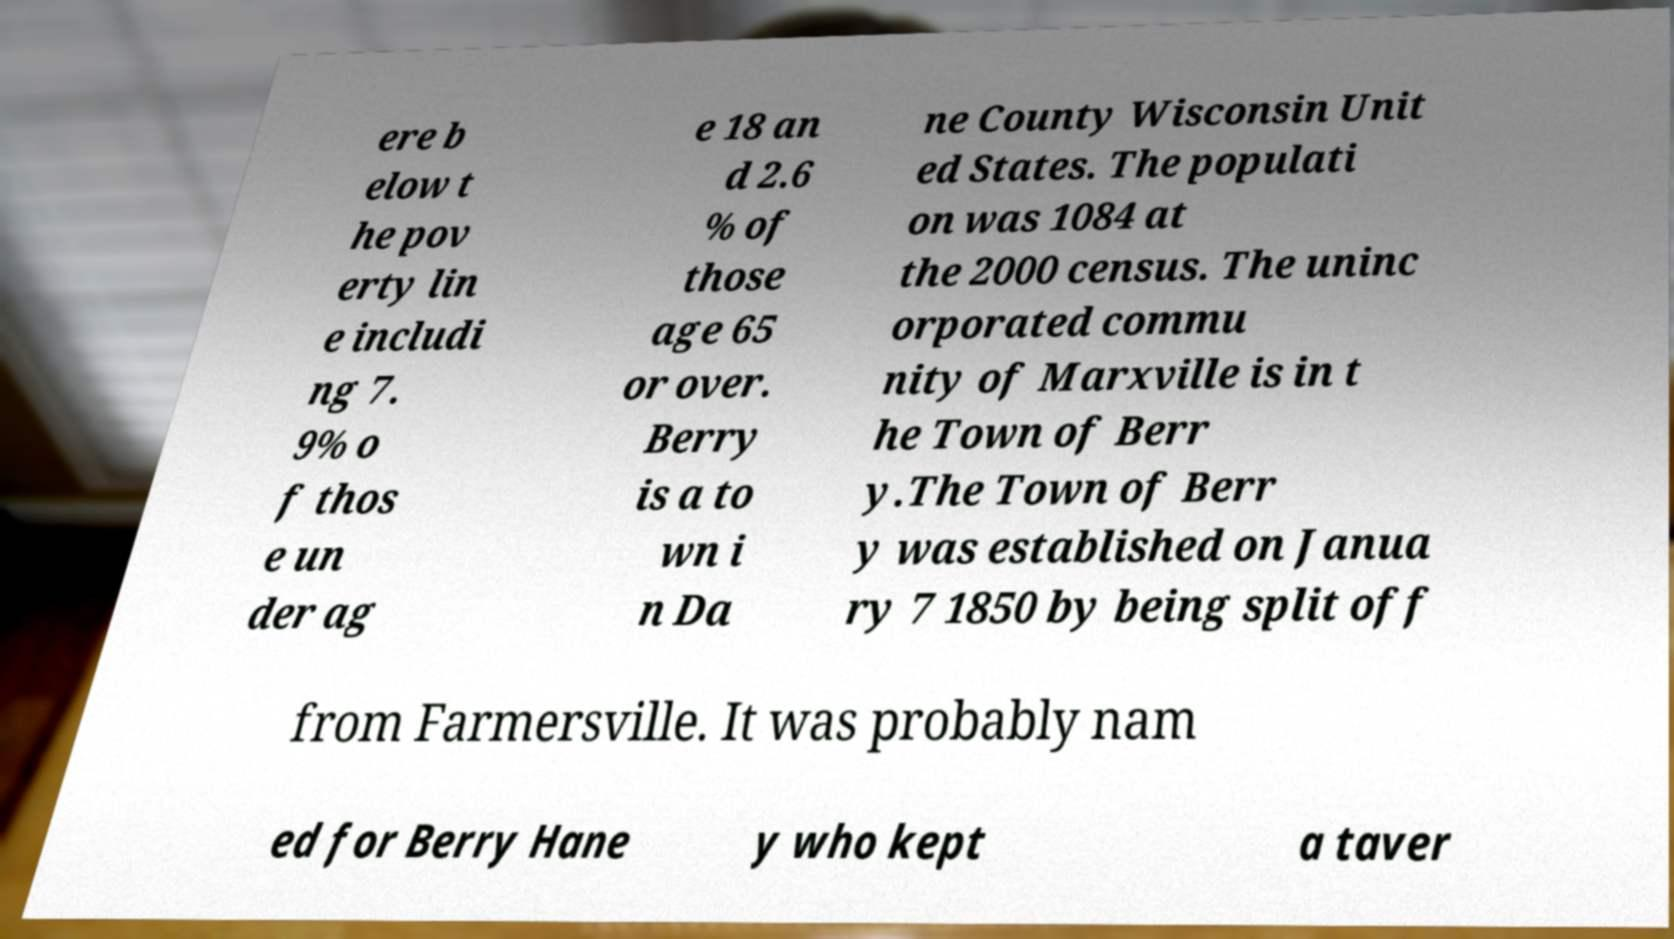Can you read and provide the text displayed in the image?This photo seems to have some interesting text. Can you extract and type it out for me? ere b elow t he pov erty lin e includi ng 7. 9% o f thos e un der ag e 18 an d 2.6 % of those age 65 or over. Berry is a to wn i n Da ne County Wisconsin Unit ed States. The populati on was 1084 at the 2000 census. The uninc orporated commu nity of Marxville is in t he Town of Berr y.The Town of Berr y was established on Janua ry 7 1850 by being split off from Farmersville. It was probably nam ed for Berry Hane y who kept a taver 